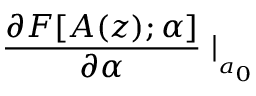<formula> <loc_0><loc_0><loc_500><loc_500>\frac { \partial F [ A ( z ) ; \alpha ] } { \partial \alpha } | _ { _ { a _ { 0 } } }</formula> 